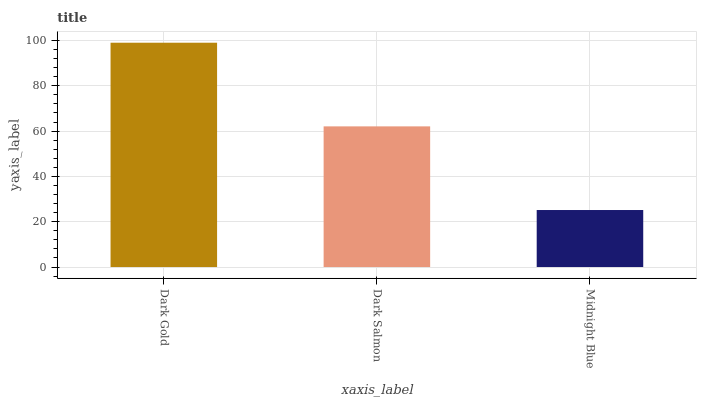Is Midnight Blue the minimum?
Answer yes or no. Yes. Is Dark Gold the maximum?
Answer yes or no. Yes. Is Dark Salmon the minimum?
Answer yes or no. No. Is Dark Salmon the maximum?
Answer yes or no. No. Is Dark Gold greater than Dark Salmon?
Answer yes or no. Yes. Is Dark Salmon less than Dark Gold?
Answer yes or no. Yes. Is Dark Salmon greater than Dark Gold?
Answer yes or no. No. Is Dark Gold less than Dark Salmon?
Answer yes or no. No. Is Dark Salmon the high median?
Answer yes or no. Yes. Is Dark Salmon the low median?
Answer yes or no. Yes. Is Dark Gold the high median?
Answer yes or no. No. Is Dark Gold the low median?
Answer yes or no. No. 